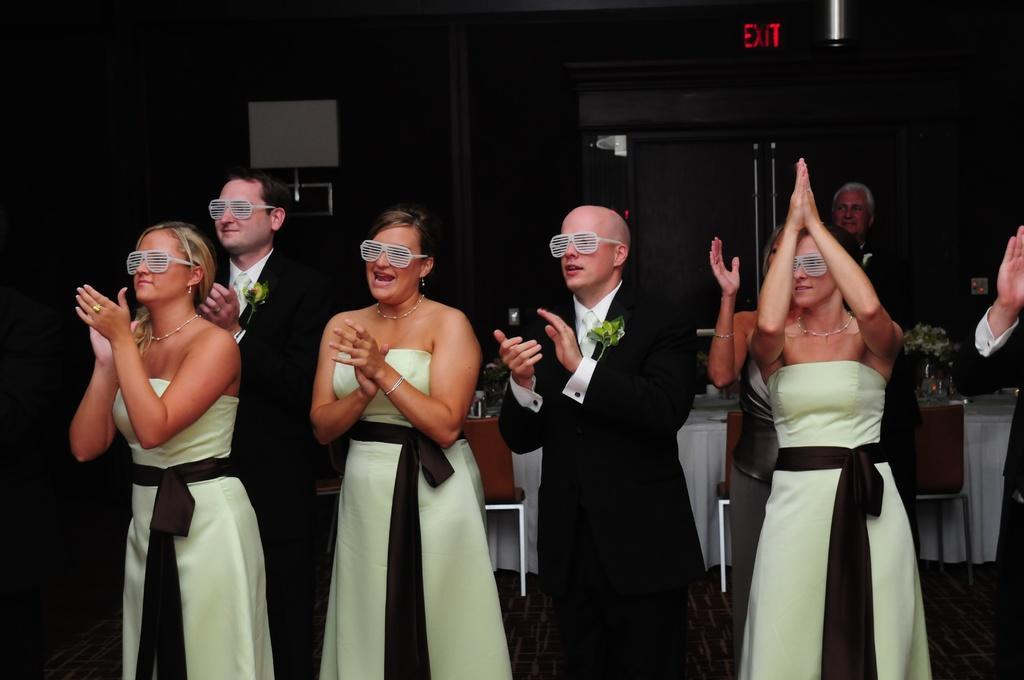Can you describe this image briefly? In this image we can see a group of people wearing glasses standing on the floor clapping their hands. On the backside we can see some chairs, a table containing some glasses and plants in a pot. We can also see a wall, door, name board and a light. 